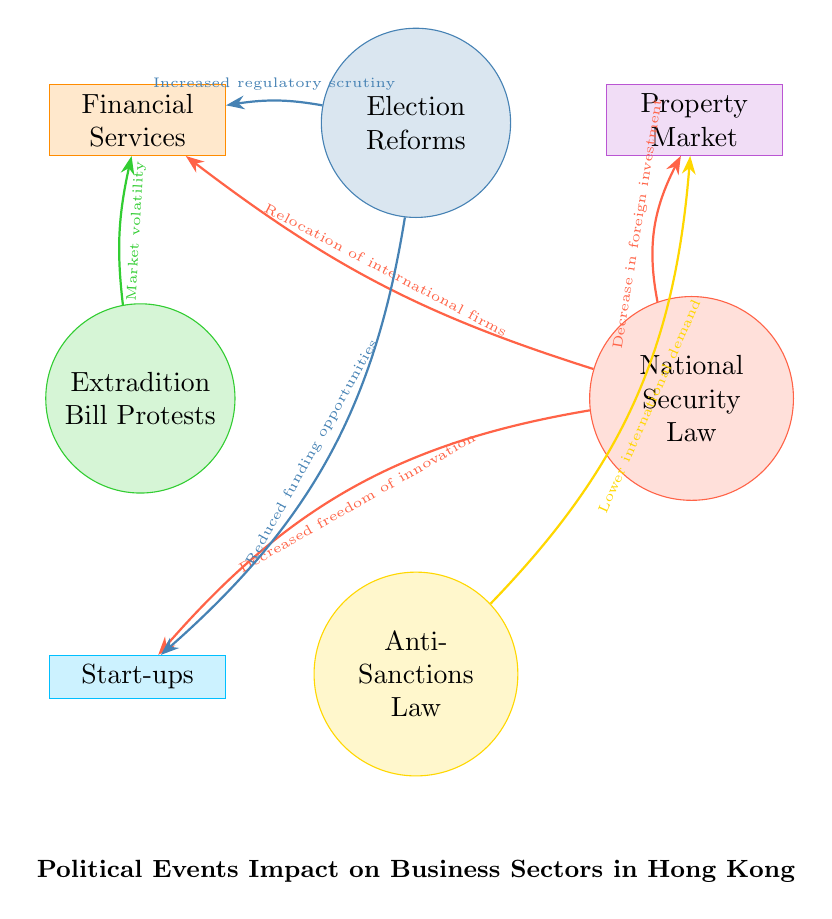What is the first political event listed in the diagram? The diagram lists the political events in a specific order, starting with "National Security Law." This can be observed by looking at the circle representing the events, which is positioned at the top and labeled.
Answer: National Security Law How many business sectors are impacted by the National Security Law? By evaluating the connections from the "National Security Law" node, I can see that there are three straight lines leading to business sectors: Property Market, Financial Services, and Start-ups. Thus, three sectors are impacted.
Answer: 3 What effect does the Anti-Sanctions Law have on the Property Market? Looking at the connection between the "Anti-Sanctions Law" and the "Property Market," there is a label stating "Lower international demand." This indicates the effect of that law on this specific business sector.
Answer: Lower international demand Which event has the most connections to the Financial Services sector? From the Financial Services node, I count three connections coming from the “National Security Law,” “Election Reforms,” and “Extradition Bill Protests.” Among these, National Security Law stands out as it is the first event and has the highest specific impact mentioned.
Answer: National Security Law What is the connection between Election Reforms and Start-ups? The diagram shows that there is a line connection from the “Election Reforms” to the “Start-ups” sector with the label "Reduced funding opportunities." This describes the specific impact of Election Reforms on Start-ups.
Answer: Reduced funding opportunities Which business sector is affected by market volatility according to the diagram? The connection labeled "Market volatility" leads from the “Extradition Bill Protests” to the “Financial Services.” Thus, this indicates that the Financial Services sector is impacted by market volatility.
Answer: Financial Services What two political events impact the Property Market? By inspecting the connections from the "Property Market" node, I find two labels: "Decrease in foreign investment" from the “National Security Law” and "Lower international demand" from the “Anti-Sanctions Law.” Therefore, these two political events impact the Property Market.
Answer: National Security Law, Anti-Sanctions Law What does the National Security Law decrease in the Start-ups sector? The connection from the National Security Law to Start-ups specifically states "Decreased freedom of innovation." This indicates the direct impact of this political law on the Start-ups.
Answer: Decreased freedom of innovation 